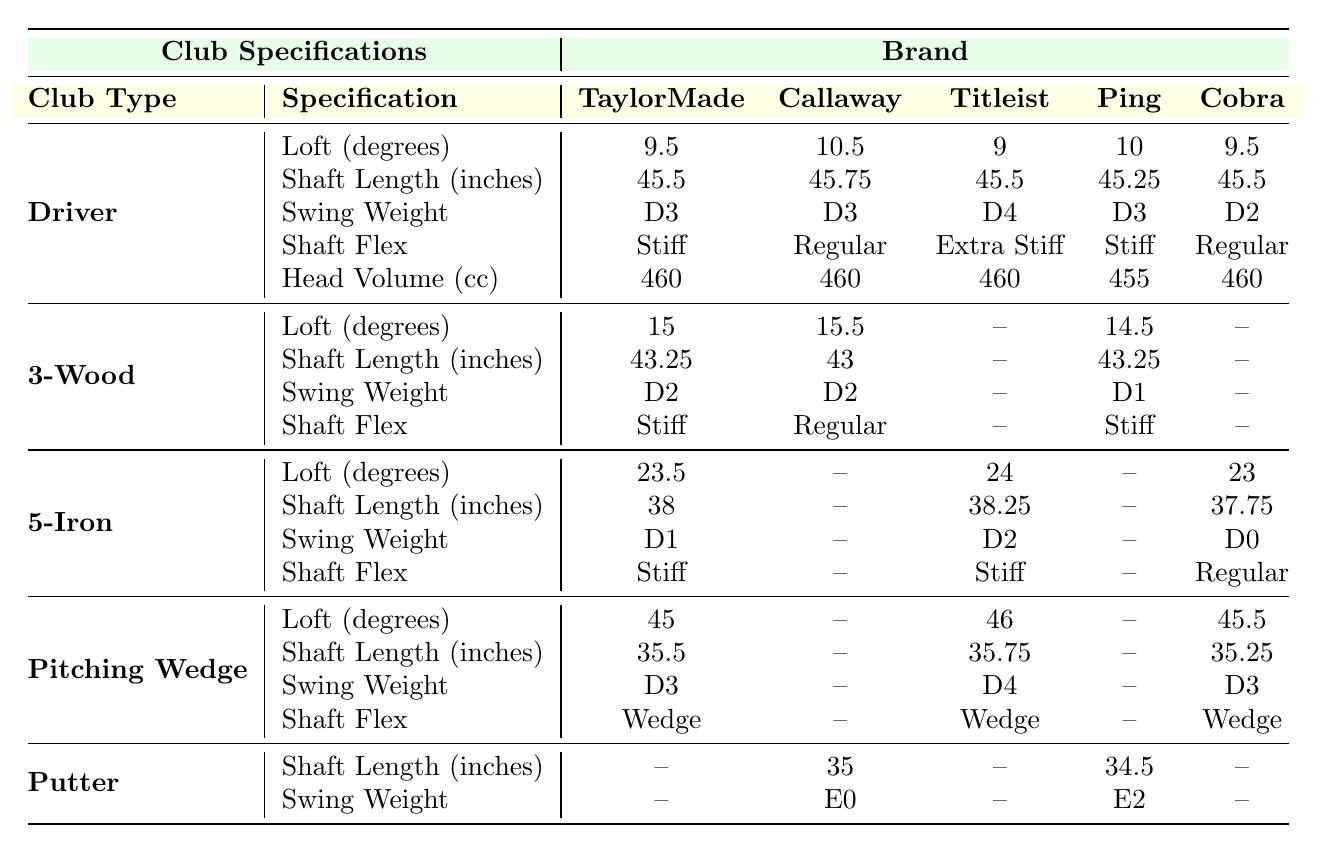What is the loft of the Titleist Driver? The table shows that the loft of the Titleist Driver is listed under the "Driver" row and the "Loft (degrees)" column. The value specified is 9 degrees.
Answer: 9 degrees Which brand has the longest shaft length in the 3-Wood category? In the 3-Wood category, the shaft lengths are 43.25 inches for TaylorMade, 43 inches for Callaway, and 14.5 inches for Ping. TaylorMade has the longest shaft length at 43.25 inches.
Answer: TaylorMade Does the Ping Driver have a higher swing weight than the TaylorMade Driver? The swing weight for the Ping Driver is D3 and for the TaylorMade Driver is D3 as well. Therefore, the answer is no, they are equal.
Answer: No Which brand has the lightest swing weight in the 5-Iron category? Looking at the 5-Iron category, the swing weights are D1 for TaylorMade, D2 for Titleist, D0 for Cobra and no entry for Callaway and Ping. Cobra has the lightest swing weight at D0.
Answer: Cobra What is the difference in loft (degrees) between the 5-Iron of Callaway and Titleist? The loft of Callaway's 5-Iron is not specified (indicated by --), while Titleist's 5-Iron has a loft of 24 degrees. The difference in loft cannot be calculated since one of the values is missing.
Answer: Cannot be calculated Which brand has a stiffer shaft flex for the Driver compared to other brands? The table indicates that the shaft flex for the TaylorMade Driver is "Stiff," the Callaway Driver "Regular," Titleist "Extra Stiff," Ping "Stiff," and Cobra "Regular." Titleist has the stiffest shaft flex categorized as "Extra Stiff."
Answer: Titleist What is the average loft of the Drivers across all brands listed? The loots are 9.5 (TaylorMade), 10.5 (Callaway), 9 (Titleist), 10 (Ping), and 9.5 (Cobra). Adding these values gives 49.5 degrees, and dividing by 5 brands results in an average of 9.9 degrees.
Answer: 9.9 degrees How does the head volume of the Ping Driver compare to that of the other brands? The head volume of the Ping Driver is 455 cc, which is lower than the 460 cc head volume for TaylorMade, Callaway, and Cobra but not applicable to Titleist as they also have 460 cc. Therefore, it's the only brand with less volume than 460 cc among others.
Answer: Lower than others What is the shaft length of the 5-Iron for the Cobra brand? In the table, the shaft length for the Cobra 5-Iron is indicated under the 5-Iron row and the "Shaft Length (inches)" column, which shows a value of 37.75 inches.
Answer: 37.75 inches Is there a Putter available from TaylorMade in the table? The table shows no entries under the Putter category for TaylorMade, as there is a lack of data specified for TaylorMade's Putter.
Answer: No 